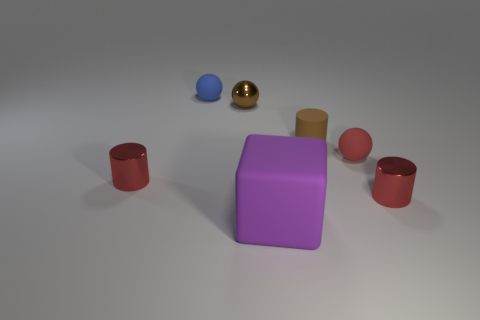Is there a brown cylinder made of the same material as the blue object?
Your answer should be very brief. Yes. Are the big thing and the small blue sphere made of the same material?
Your answer should be very brief. Yes. There is a small brown object to the left of the large cube; how many small shiny objects are right of it?
Offer a very short reply. 1. What number of blue things are either large rubber cylinders or small metallic things?
Offer a terse response. 0. What shape is the small red metallic object that is on the left side of the cylinder that is in front of the red metallic thing that is left of the cube?
Provide a succinct answer. Cylinder. What is the color of the rubber cylinder that is the same size as the brown shiny object?
Your answer should be compact. Brown. How many red metal objects have the same shape as the tiny brown matte thing?
Keep it short and to the point. 2. Is the size of the blue matte object the same as the cylinder that is to the left of the blue matte sphere?
Offer a terse response. Yes. The tiny thing that is in front of the red metal cylinder on the left side of the small brown cylinder is what shape?
Offer a very short reply. Cylinder. Is the number of small red cylinders to the right of the brown matte object less than the number of big green shiny balls?
Offer a very short reply. No. 